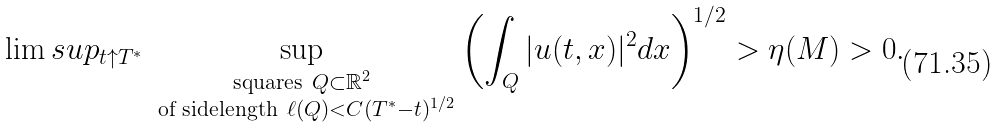<formula> <loc_0><loc_0><loc_500><loc_500>\lim s u p _ { t \uparrow T ^ { * } } \sup _ { \substack { \text {squares} \ Q \subset \mathbb { R } ^ { 2 } \\ \ \text {of sidelength} \ \ell ( Q ) < C ( T ^ { * } - t ) ^ { 1 / 2 } } } \left ( \int _ { Q } | u ( t , x ) | ^ { 2 } d x \right ) ^ { 1 / 2 } > \eta ( M ) > 0 .</formula> 